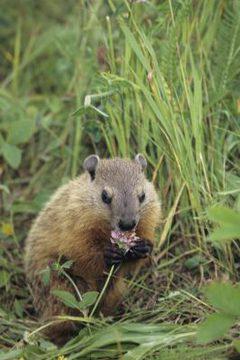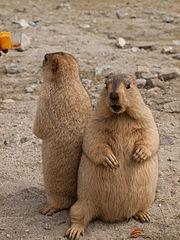The first image is the image on the left, the second image is the image on the right. Assess this claim about the two images: "there is a gopher sitting with food in its hands". Correct or not? Answer yes or no. Yes. The first image is the image on the left, the second image is the image on the right. For the images shown, is this caption "There are 3 prairie dogs with at least 2 of them standing upright." true? Answer yes or no. Yes. 